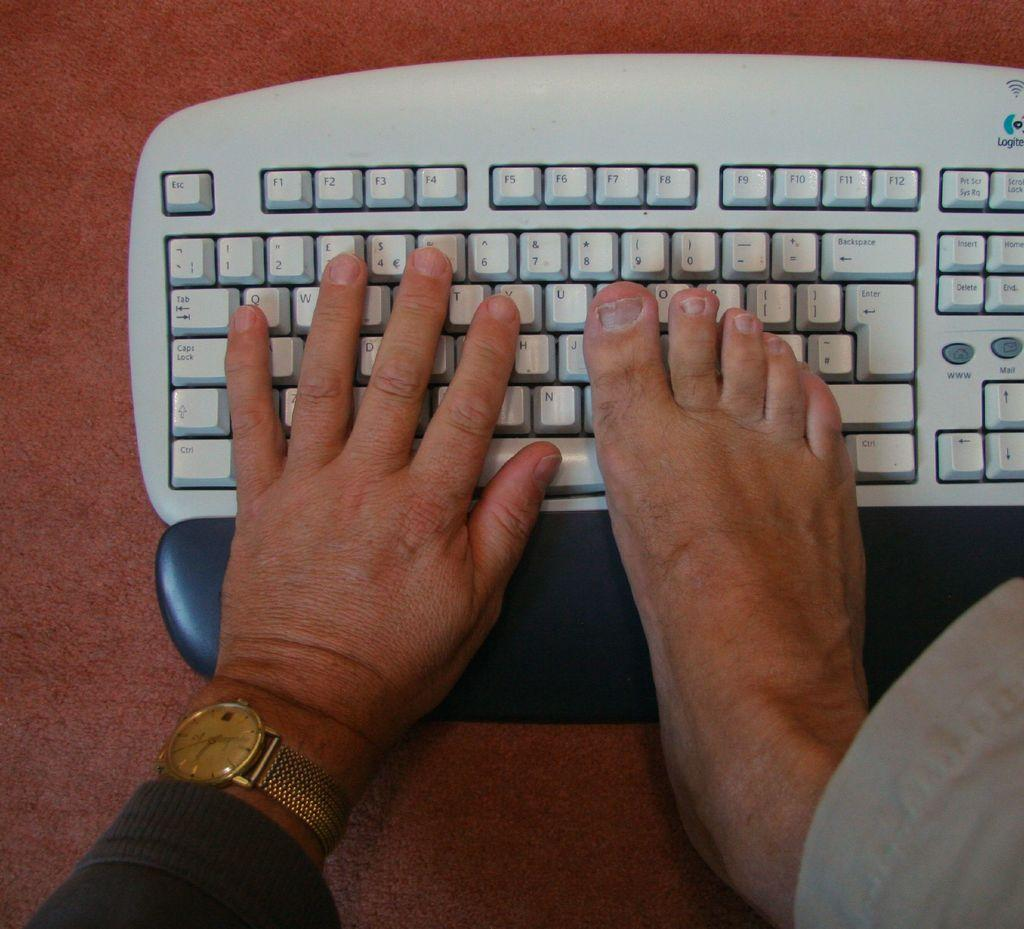<image>
Write a terse but informative summary of the picture. Person typing on the keyboard with the ESC key on the top left. 